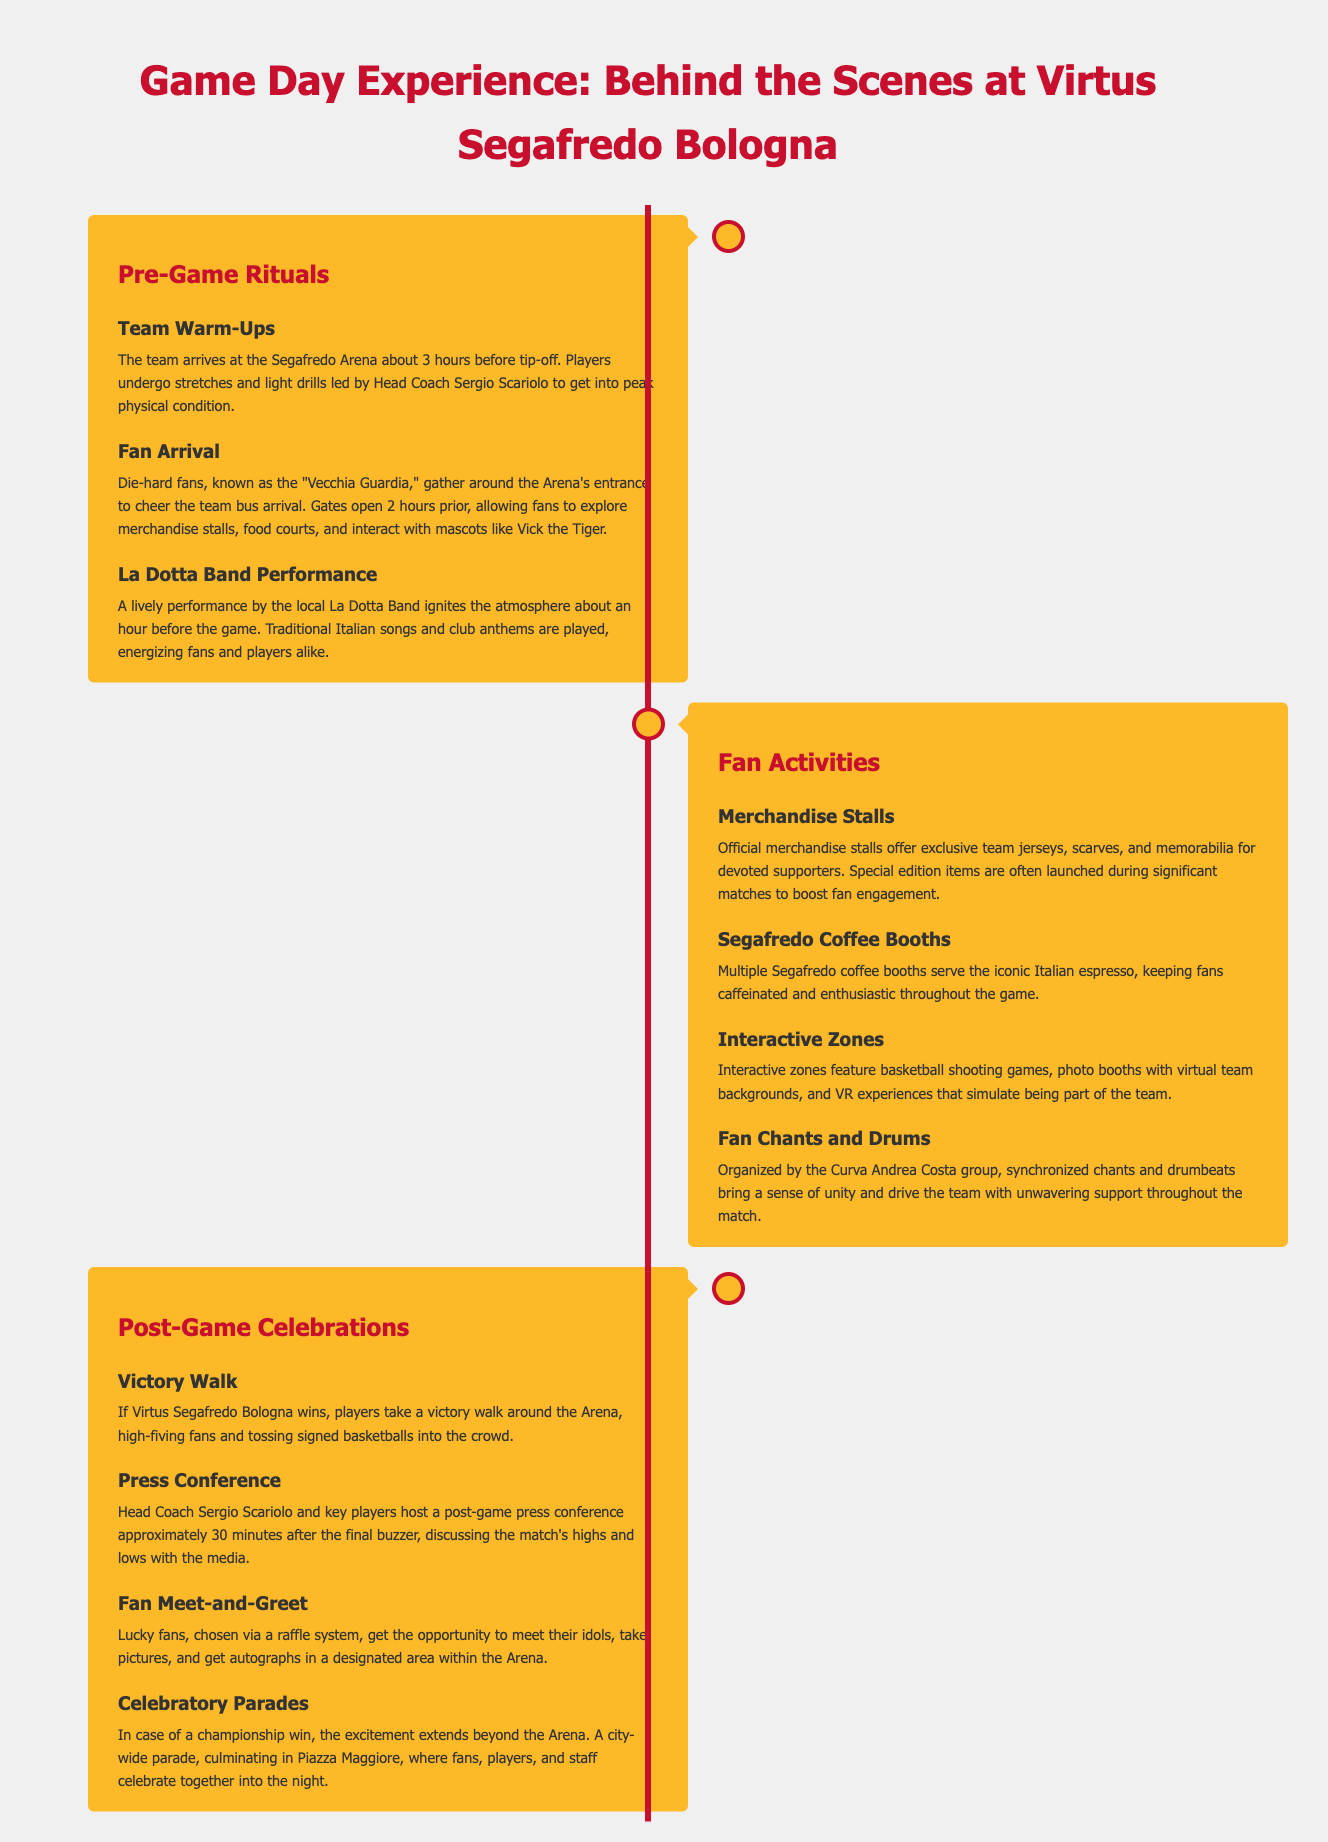What time do players arrive at the arena? Players arrive at the Segafredo Arena about 3 hours before tip-off.
Answer: 3 hours What band performs before the game? A lively performance by the local band takes place about an hour before the game starts.
Answer: La Dotta Band What activities do fan chant groups engage in? The Curva Andrea Costa group organizes synchronized chants and drumbeats to support the team.
Answer: Synchronized chants and drumbeats How long after the game is the press conference held? The press conference is hosted approximately 30 minutes after the final buzzer.
Answer: 30 minutes What do players do during a victory walk? Players take a victory walk around the Arena, high-fiving fans and tossing signed basketballs into the crowd.
Answer: High-fiving fans and tossing signed basketballs What types of coffee are served at the booths? Multiple booths serve the iconic Italian coffee known for keeping fans enthusiastic throughout the game.
Answer: Italian espresso 